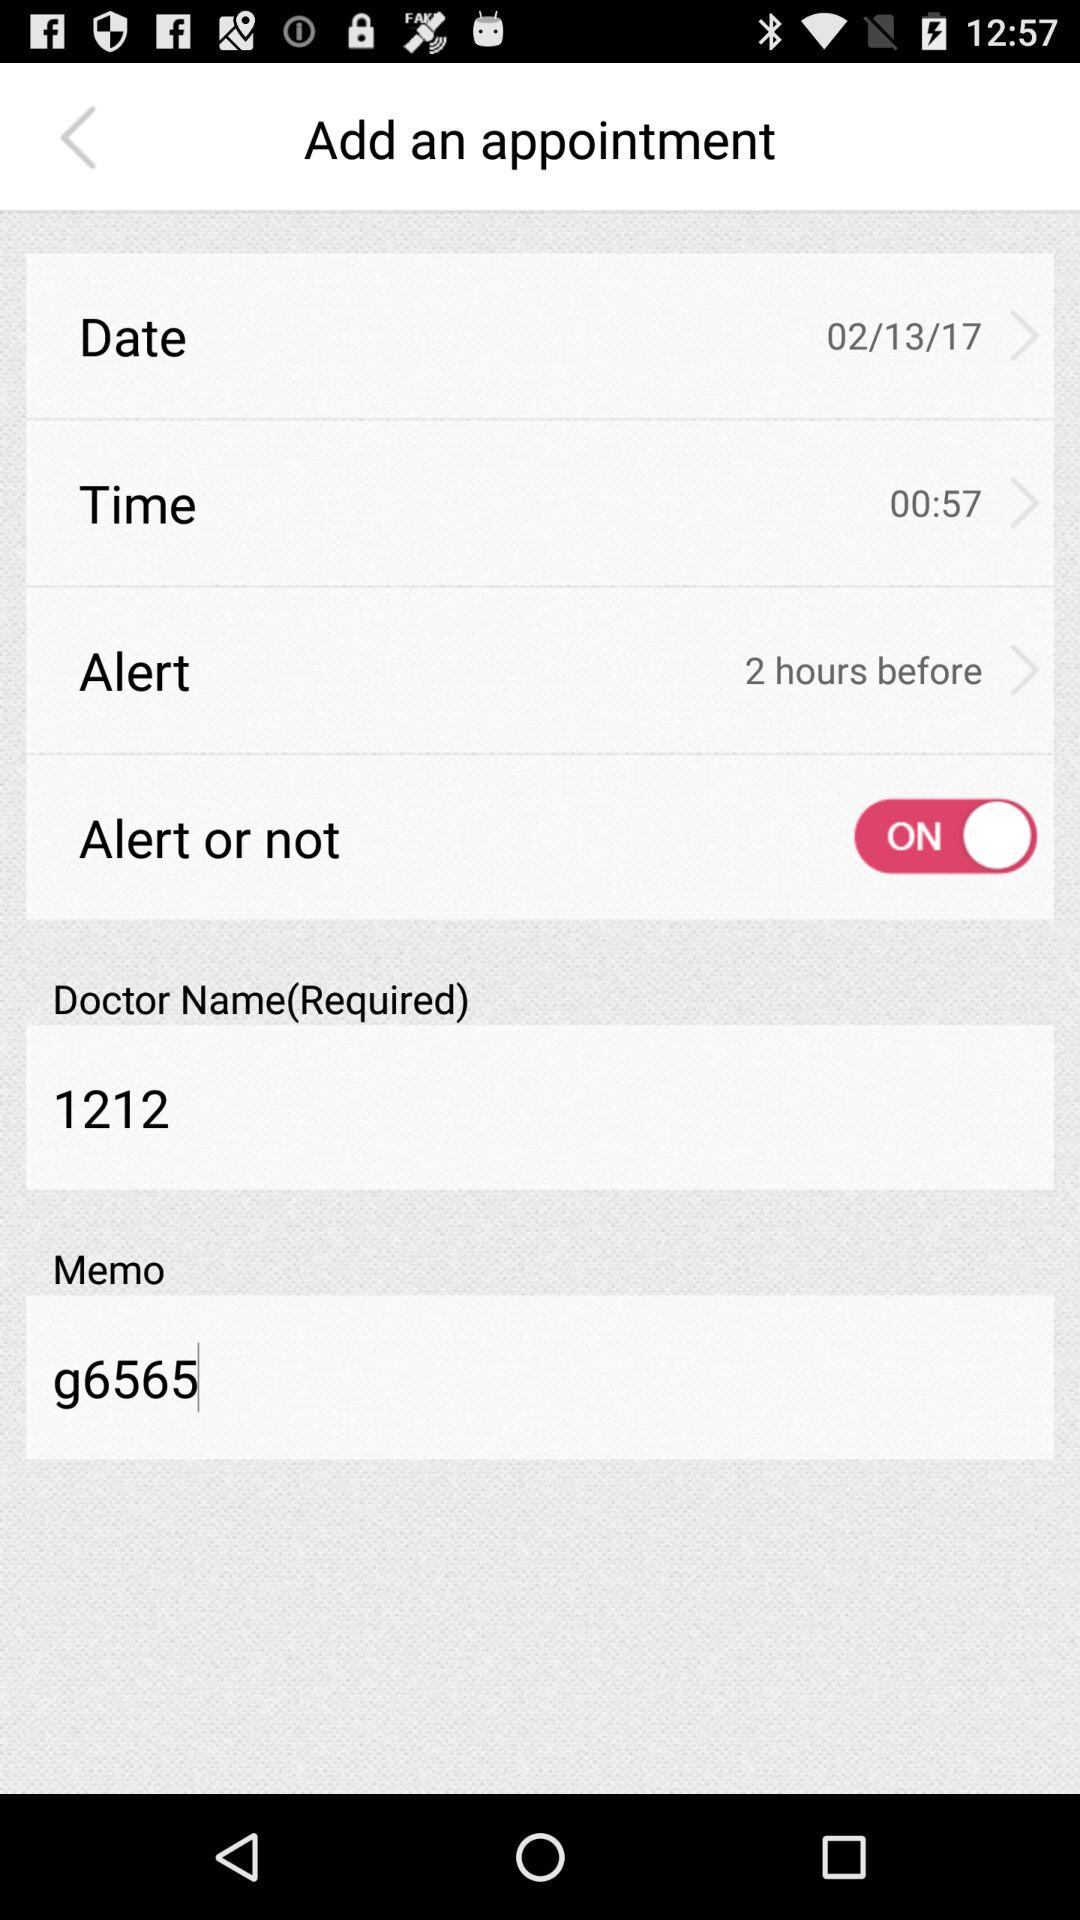How many hours before is the alert set for?
Answer the question using a single word or phrase. 2 hours 